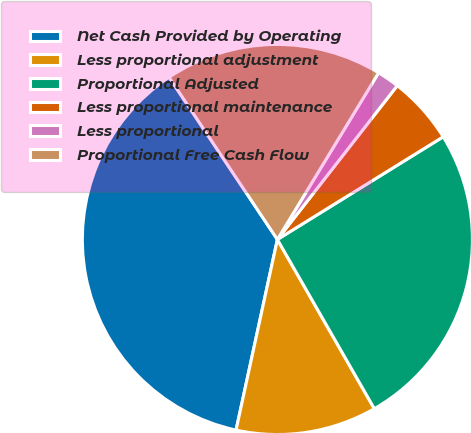Convert chart to OTSL. <chart><loc_0><loc_0><loc_500><loc_500><pie_chart><fcel>Net Cash Provided by Operating<fcel>Less proportional adjustment<fcel>Proportional Adjusted<fcel>Less proportional maintenance<fcel>Less proportional<fcel>Proportional Free Cash Flow<nl><fcel>37.23%<fcel>11.68%<fcel>25.54%<fcel>5.64%<fcel>1.85%<fcel>18.05%<nl></chart> 